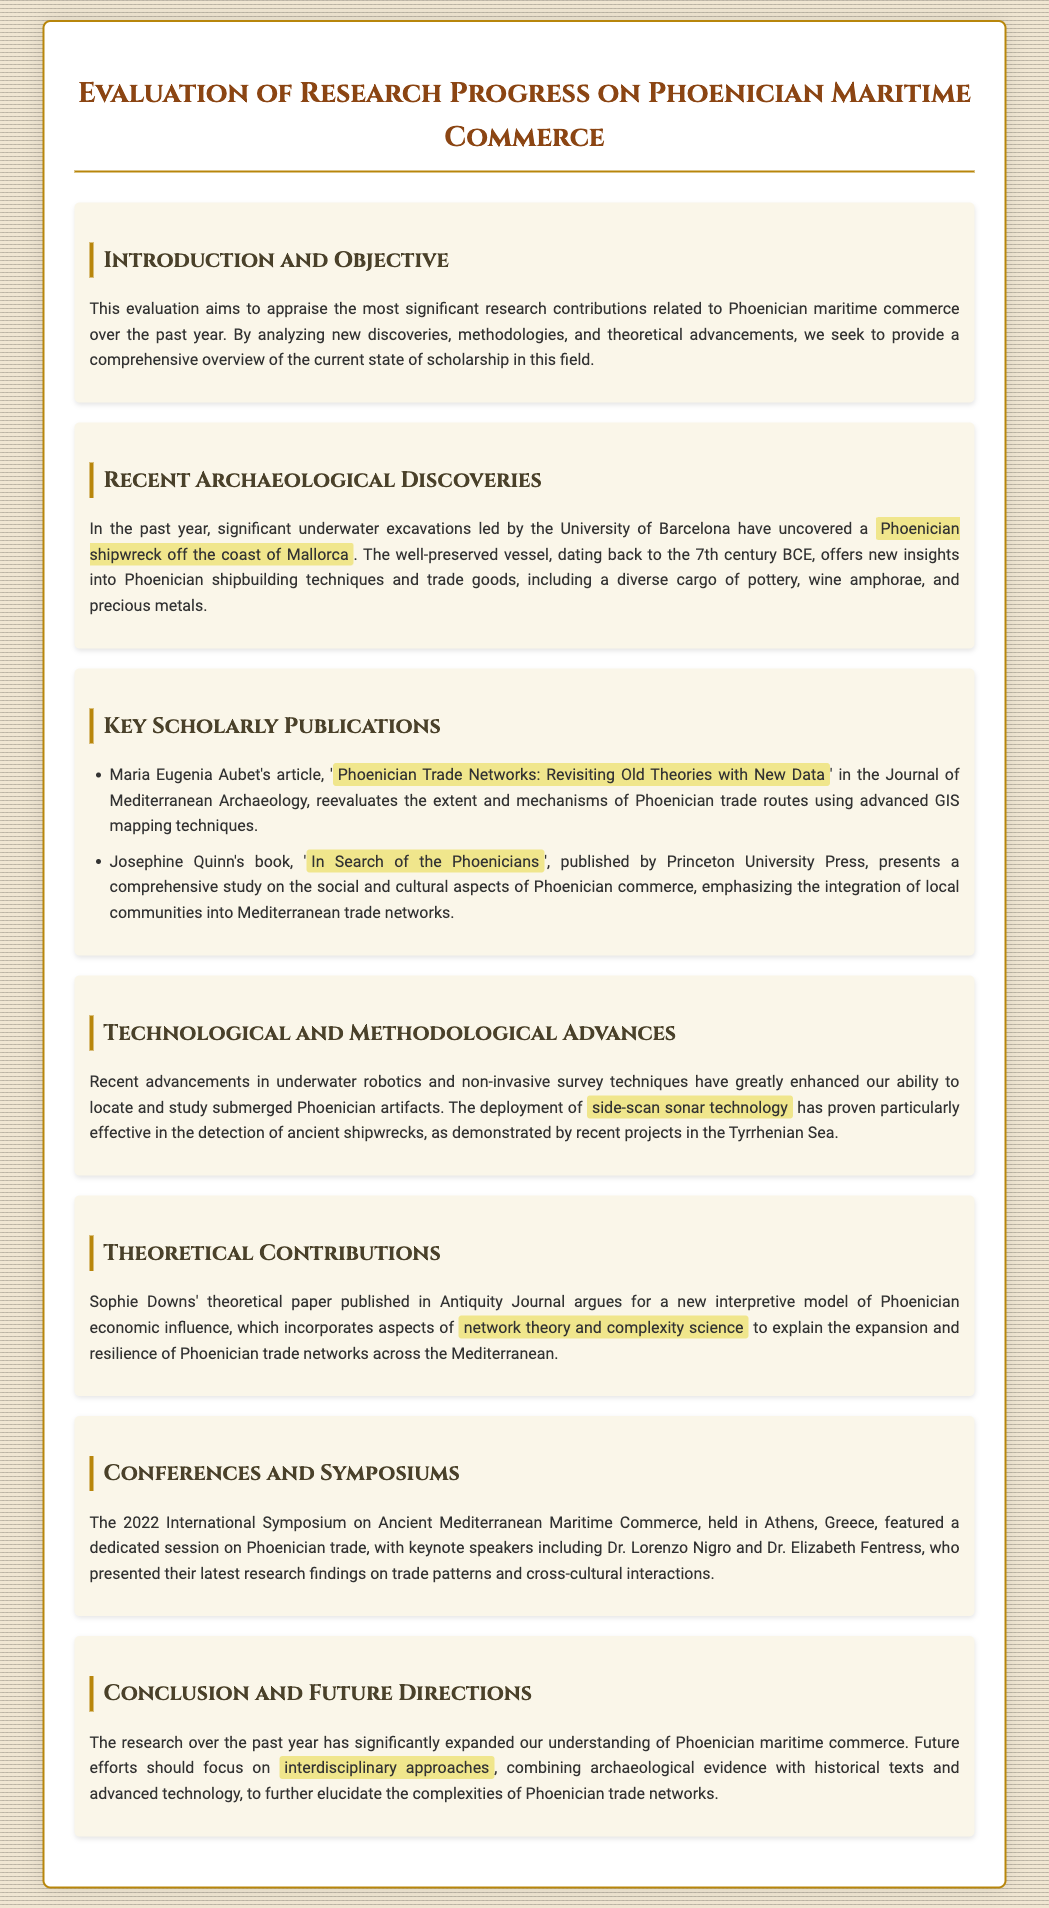What is the focus of the evaluation? The focus of the evaluation is to appraise significant research contributions related to Phoenician maritime commerce.
Answer: Phoenician maritime commerce What was uncovered by the University of Barcelona? The University of Barcelona uncovered a Phoenician shipwreck off the coast of Mallorca.
Answer: Phoenician shipwreck Who authored the article on Phoenician trade networks? Maria Eugenia Aubet authored the article, "Phoenician Trade Networks: Revisiting Old Theories with New Data".
Answer: Maria Eugenia Aubet What technological advancement is mentioned for locating artifacts? Side-scan sonar technology is mentioned for locating submerged Phoenician artifacts.
Answer: Side-scan sonar technology What is the title of Josephine Quinn's book? The title of Josephine Quinn's book is "In Search of the Phoenicians".
Answer: In Search of the Phoenicians What year was the International Symposium on Ancient Mediterranean Maritime Commerce held? The symposium was held in 2022.
Answer: 2022 Which theoretical model is highlighted in Sophie Downs' paper? The highlighted model incorporates aspects of network theory and complexity science.
Answer: Network theory and complexity science What are future research efforts suggested to focus on? Future research efforts should focus on interdisciplinary approaches.
Answer: Interdisciplinary approaches 